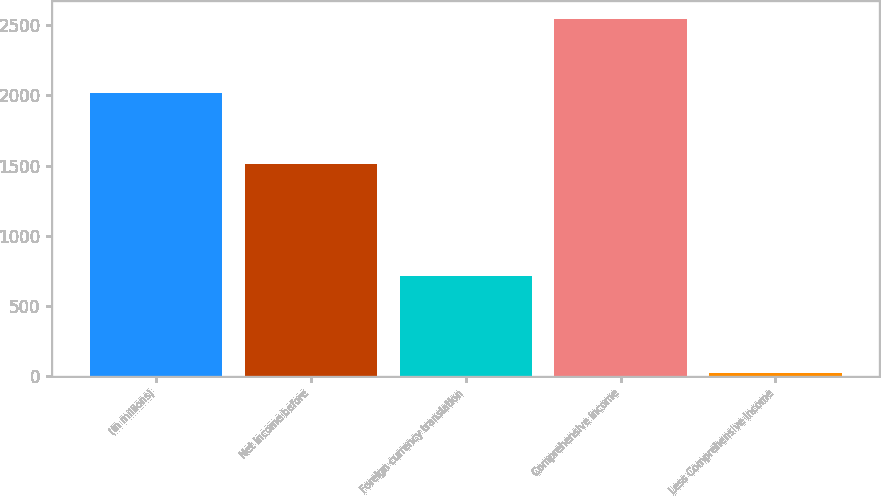Convert chart to OTSL. <chart><loc_0><loc_0><loc_500><loc_500><bar_chart><fcel>(In millions)<fcel>Net income before<fcel>Foreign currency translation<fcel>Comprehensive income<fcel>Less Comprehensive income<nl><fcel>2017<fcel>1512<fcel>717<fcel>2542<fcel>20<nl></chart> 